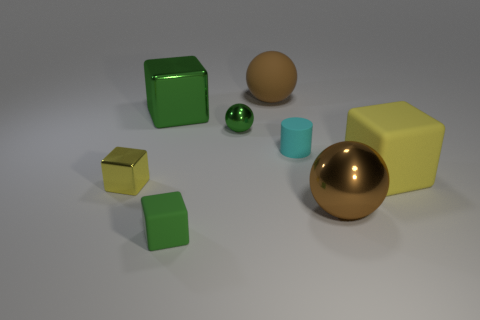Subtract all small yellow metal cubes. How many cubes are left? 3 Add 1 small shiny balls. How many objects exist? 9 Subtract all brown spheres. How many spheres are left? 1 Subtract all cylinders. How many objects are left? 7 Subtract all purple blocks. How many green balls are left? 1 Subtract all tiny metal balls. Subtract all yellow rubber blocks. How many objects are left? 6 Add 4 small matte cylinders. How many small matte cylinders are left? 5 Add 8 large green shiny objects. How many large green shiny objects exist? 9 Subtract 0 purple spheres. How many objects are left? 8 Subtract all green cubes. Subtract all cyan cylinders. How many cubes are left? 2 